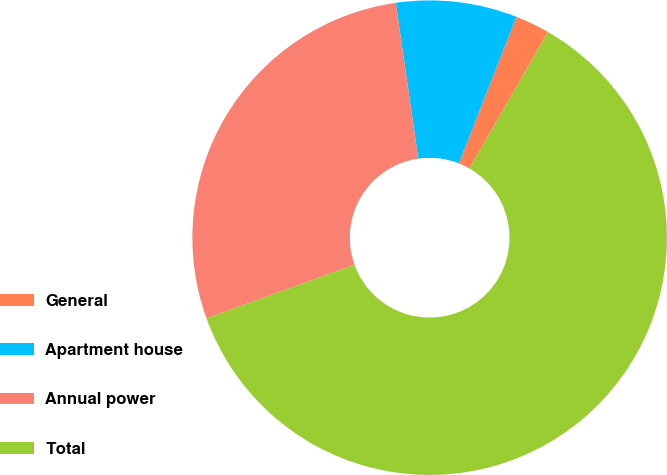Convert chart. <chart><loc_0><loc_0><loc_500><loc_500><pie_chart><fcel>General<fcel>Apartment house<fcel>Annual power<fcel>Total<nl><fcel>2.35%<fcel>8.24%<fcel>28.24%<fcel>61.18%<nl></chart> 